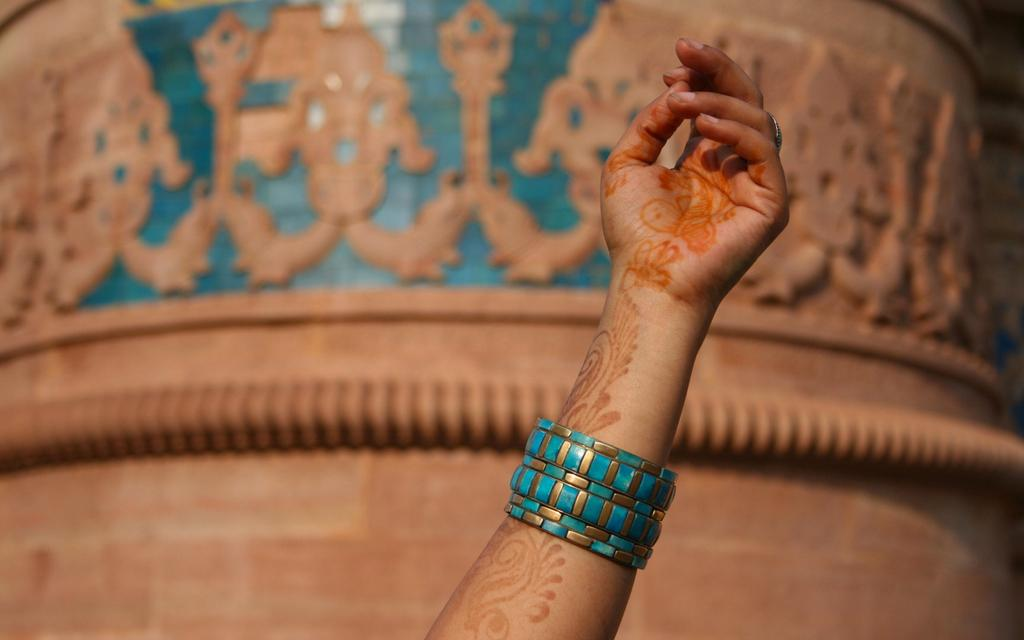What part of a person can be seen in the image? There is a person's hand in the image. What is the person wearing on their hand? The person is wearing bangles. What can be seen in the background of the image? There is a background structure visible in the image. How does the person's hand help to maintain balance in the image? The person's hand does not appear to be involved in maintaining balance in the image; it is simply a hand wearing bangles. 